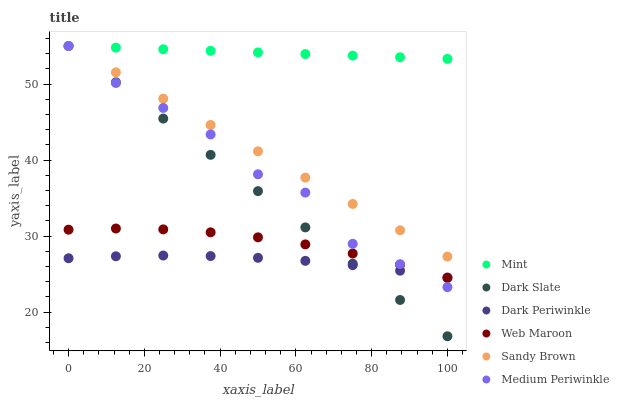Does Dark Periwinkle have the minimum area under the curve?
Answer yes or no. Yes. Does Mint have the maximum area under the curve?
Answer yes or no. Yes. Does Web Maroon have the minimum area under the curve?
Answer yes or no. No. Does Web Maroon have the maximum area under the curve?
Answer yes or no. No. Is Dark Slate the smoothest?
Answer yes or no. Yes. Is Medium Periwinkle the roughest?
Answer yes or no. Yes. Is Mint the smoothest?
Answer yes or no. No. Is Mint the roughest?
Answer yes or no. No. Does Dark Slate have the lowest value?
Answer yes or no. Yes. Does Web Maroon have the lowest value?
Answer yes or no. No. Does Sandy Brown have the highest value?
Answer yes or no. Yes. Does Web Maroon have the highest value?
Answer yes or no. No. Is Web Maroon less than Mint?
Answer yes or no. Yes. Is Mint greater than Web Maroon?
Answer yes or no. Yes. Does Mint intersect Sandy Brown?
Answer yes or no. Yes. Is Mint less than Sandy Brown?
Answer yes or no. No. Is Mint greater than Sandy Brown?
Answer yes or no. No. Does Web Maroon intersect Mint?
Answer yes or no. No. 